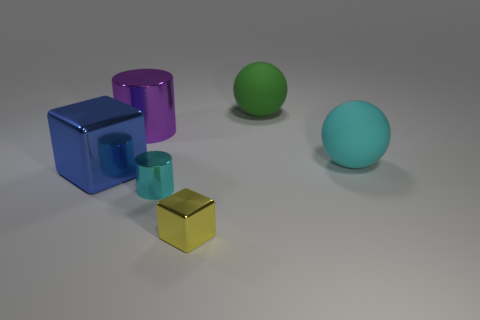Is there anything else that is the same color as the large metal cylinder?
Your answer should be very brief. No. There is a big metallic cylinder that is behind the big blue metallic thing that is in front of the big green object; what is its color?
Offer a terse response. Purple. Are any large blue metal objects visible?
Your answer should be compact. Yes. What is the color of the thing that is behind the cyan sphere and in front of the green matte sphere?
Make the answer very short. Purple. There is a metal cylinder that is in front of the big metal cylinder; is its size the same as the shiny cylinder that is behind the cyan matte ball?
Ensure brevity in your answer.  No. What number of other objects are the same size as the yellow metal block?
Make the answer very short. 1. There is a tiny object that is behind the small yellow thing; what number of purple metallic cylinders are right of it?
Your answer should be compact. 0. Is the number of big purple metallic things that are behind the green ball less than the number of gray rubber things?
Your answer should be compact. No. What shape is the big purple metallic thing that is to the left of the small metallic object on the left side of the cube to the right of the cyan shiny thing?
Provide a succinct answer. Cylinder. Does the large cyan thing have the same shape as the tiny yellow thing?
Your answer should be compact. No. 